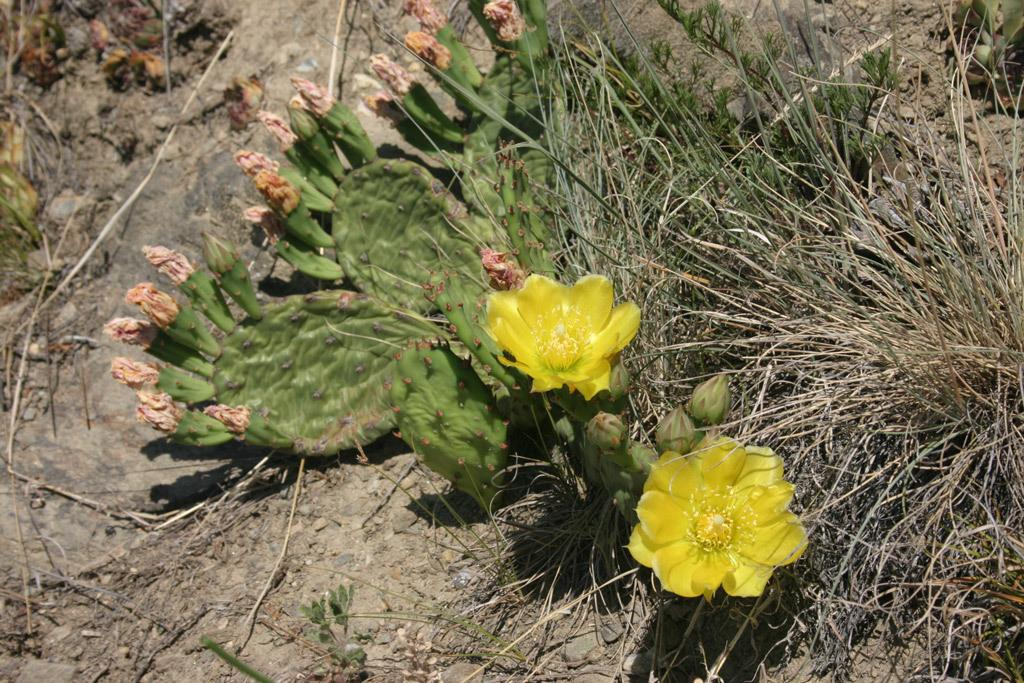What color are the flowers in the image? The flowers in the image are yellow. What type of plants are present in the image? There are flower plants in the image. What type of vegetation is visible in the image? There is grass visible in the image. What else can be seen on the ground in the image? There are other objects on the ground in the image. How many basketballs are visible in the image? There are no basketballs present in the image. What is the fifth object on the ground in the image? The provided facts do not mention a fifth object on the ground, so we cannot answer this question. 